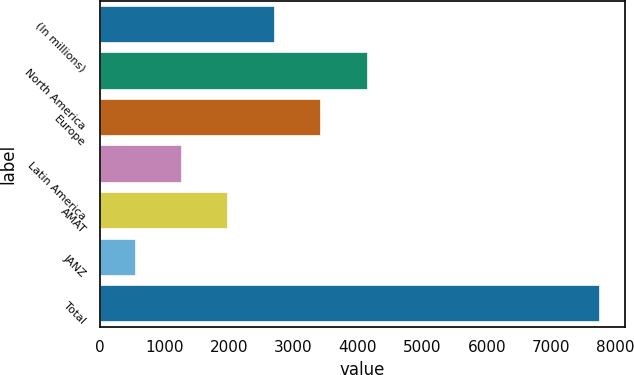Convert chart. <chart><loc_0><loc_0><loc_500><loc_500><bar_chart><fcel>(In millions)<fcel>North America<fcel>Europe<fcel>Latin America<fcel>AMAT<fcel>JANZ<fcel>Total<nl><fcel>2708.96<fcel>4149.4<fcel>3429.18<fcel>1268.52<fcel>1988.74<fcel>548.3<fcel>7750.5<nl></chart> 